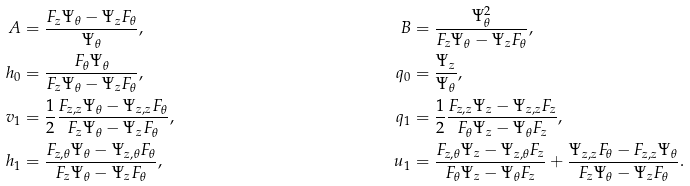Convert formula to latex. <formula><loc_0><loc_0><loc_500><loc_500>A & = \frac { F _ { z } \Psi _ { \theta } - \Psi _ { z } F _ { \theta } } { \Psi _ { \theta } } , & B & = \frac { \Psi _ { \theta } ^ { 2 } } { F _ { z } \Psi _ { \theta } - \Psi _ { z } F _ { \theta } } , \\ h _ { 0 } & = \frac { F _ { \theta } \Psi _ { \theta } } { F _ { z } \Psi _ { \theta } - \Psi _ { z } F _ { \theta } } , & q _ { 0 } & = \frac { \Psi _ { z } } { \Psi _ { \theta } } , \\ v _ { 1 } & = \frac { 1 } { 2 } \frac { F _ { z , z } \Psi _ { \theta } - \Psi _ { z , z } F _ { \theta } } { F _ { z } \Psi _ { \theta } - \Psi _ { z } F _ { \theta } } , & q _ { 1 } & = \frac { 1 } { 2 } \frac { F _ { z , z } \Psi _ { z } - \Psi _ { z , z } F _ { z } } { F _ { \theta } \Psi _ { z } - \Psi _ { \theta } F _ { z } } , \\ h _ { 1 } & = \frac { F _ { z , \theta } \Psi _ { \theta } - \Psi _ { z , \theta } F _ { \theta } } { F _ { z } \Psi _ { \theta } - \Psi _ { z } F _ { \theta } } , & u _ { 1 } & = \frac { F _ { z , \theta } \Psi _ { z } - \Psi _ { z , \theta } F _ { z } } { F _ { \theta } \Psi _ { z } - \Psi _ { \theta } F _ { z } } + \frac { \Psi _ { z , z } F _ { \theta } - F _ { z , z } \Psi _ { \theta } } { F _ { z } \Psi _ { \theta } - \Psi _ { z } F _ { \theta } } .</formula> 